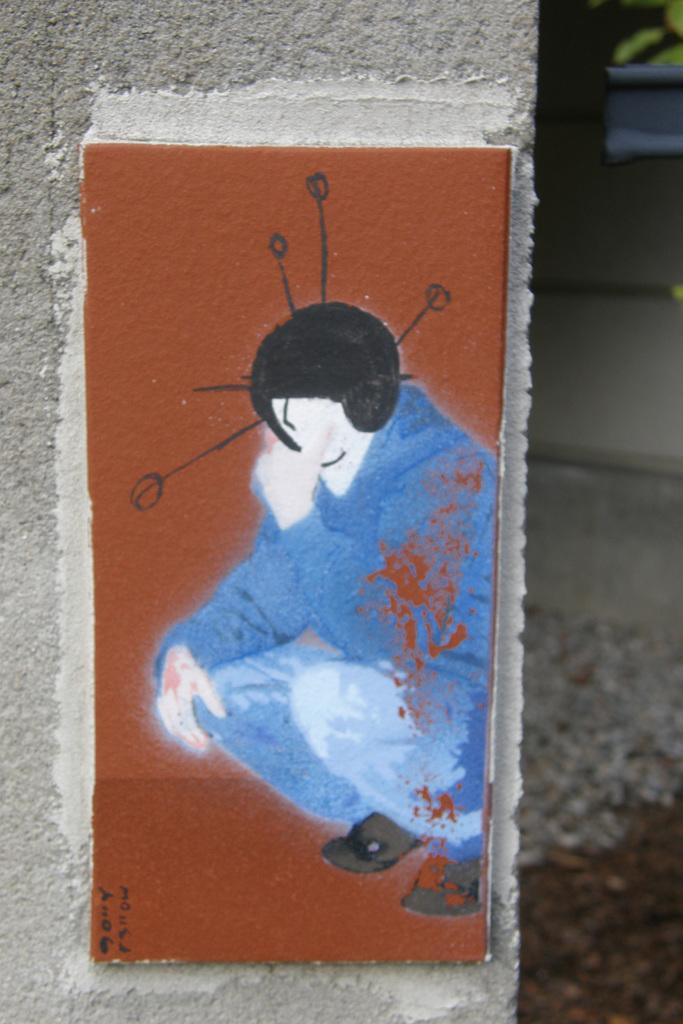Could you give a brief overview of what you see in this image? To the left side of the image there is a pillar with poster. And the poster is in brown color. In the poster there is a person with blue dress and there is a black helmet on the head. 